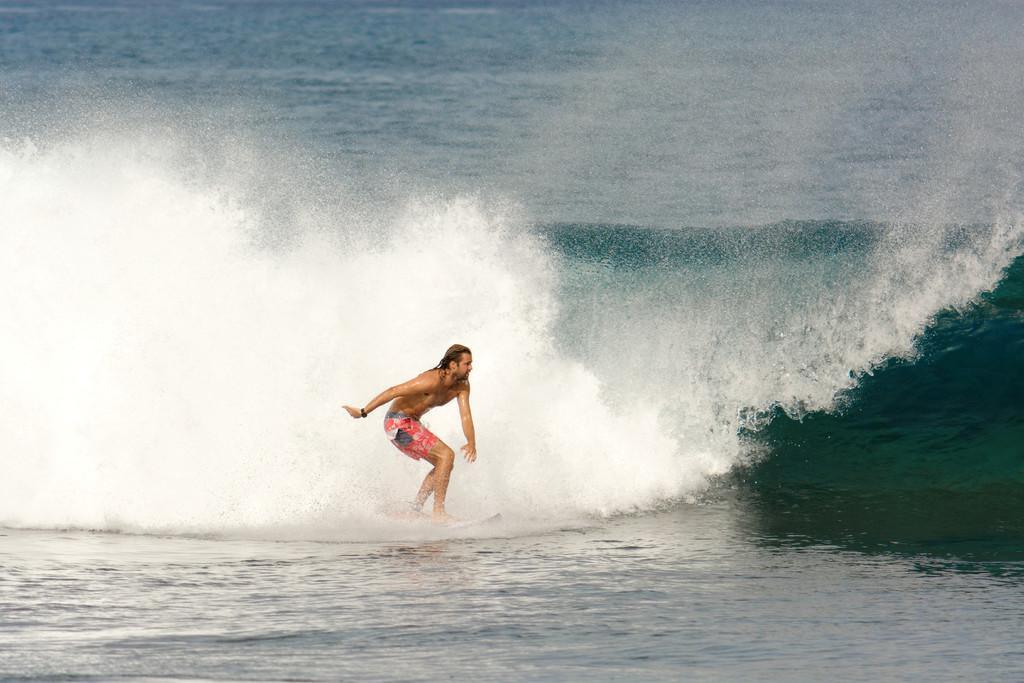How would you summarize this image in a sentence or two? In this image I can see a person in the water. The person is wearing an orange color short and I can also see a surfboard. 